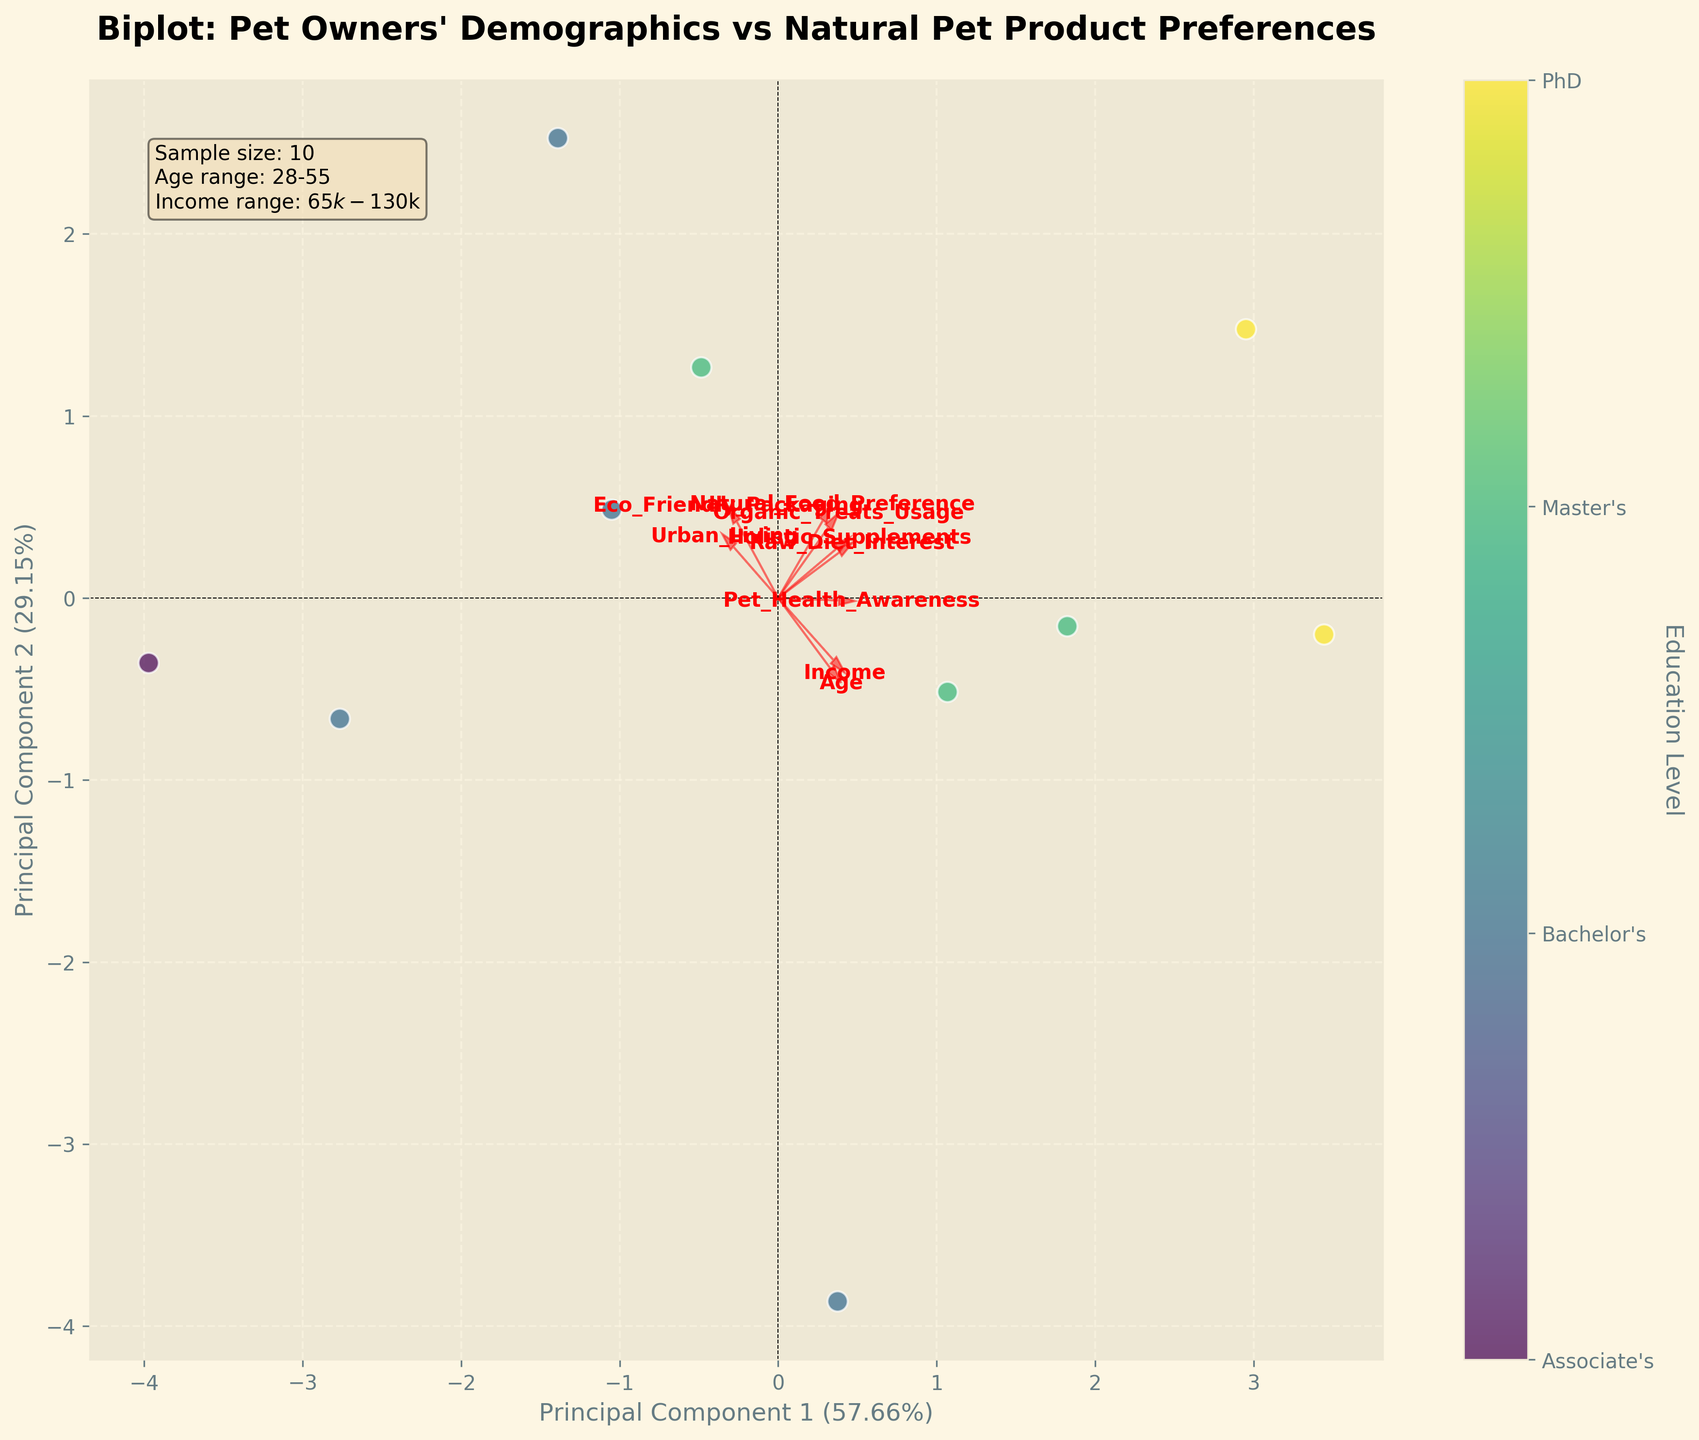What's the title of the figure? The title is prominently displayed at the top of the figure in a larger and bold font.
Answer: Biplot: Pet Owners' Demographics vs Natural Pet Product Preferences Which feature vector appears to be the longest? Observe the length of the red arrows representing each feature. The longest arrow corresponds to the feature with the highest variance explained by the principal components.
Answer: Age How does Urban_Living correlate with the principal components? Look at the direction and length of the Urban_Living arrow. It points towards the positive side of both principal components, indicating a positive correlation with both.
Answer: Positively correlates with both How many distinct education levels are represented in the color legend? Check the color legend that displays different education levels. Count the number of unique labels.
Answer: Four What percentage of variance is explained by Principal Component 1? This information is displayed on the x-axis label as a part of Principal Component 1.
Answer: Approximately 50.2% Compare the correlation of Income and Raw_Diet_Interest with the principal components. Note the angles and directions of the arrows for Income and Raw_Diet_Interest. Income has a more significant projection on Principal Component 1, while Raw_Diet_Interest has a moderate projection on both components.
Answer: Income has a higher correlation with Principal Component 1 than Raw_Diet_Interest Are there any features that appear to have a minimal influence on Principal Component 2? Look at the arrows and see which ones are almost parallel to the x-axis (Principal Component 1), indicating a minimal projection on Principal Component 2.
Answer: Income What is the relationship between Pet_Health_Awareness and Natural_Food_Preference? Check the arrows for Pet_Health_Awareness and Natural_Food_Preference. Their closeness indicates they move together.
Answer: They are closely related and positively correlated Between Age and Organic_Treats_Usage, which has a larger impact on Principal Component 2? Compare the projection lengths of the arrows for Age and Organic_Treats_Usage on Principal Component 2 (y-axis).
Answer: Organic_Treats_Usage Where is the color legend located in the figure? The position of the color legend in the figure is usually at the side of the plot area.
Answer: Right side 